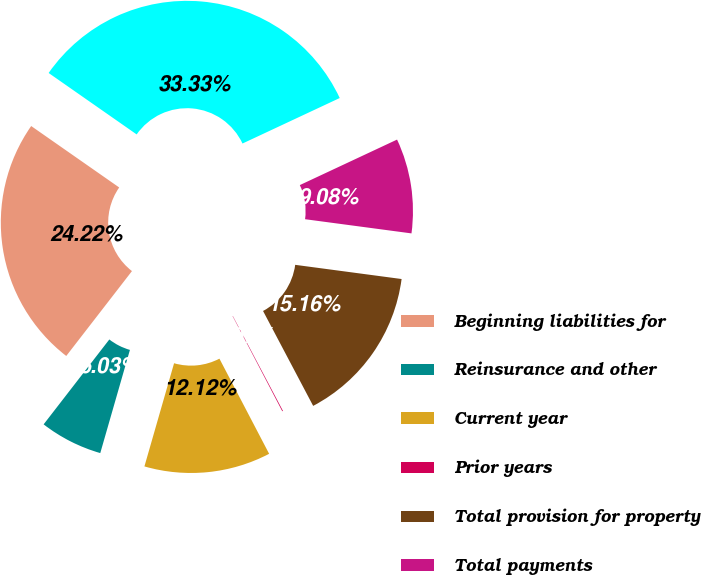Convert chart to OTSL. <chart><loc_0><loc_0><loc_500><loc_500><pie_chart><fcel>Beginning liabilities for<fcel>Reinsurance and other<fcel>Current year<fcel>Prior years<fcel>Total provision for property<fcel>Total payments<fcel>Ending liabilities for<nl><fcel>24.22%<fcel>6.03%<fcel>12.12%<fcel>0.07%<fcel>15.16%<fcel>9.08%<fcel>33.34%<nl></chart> 